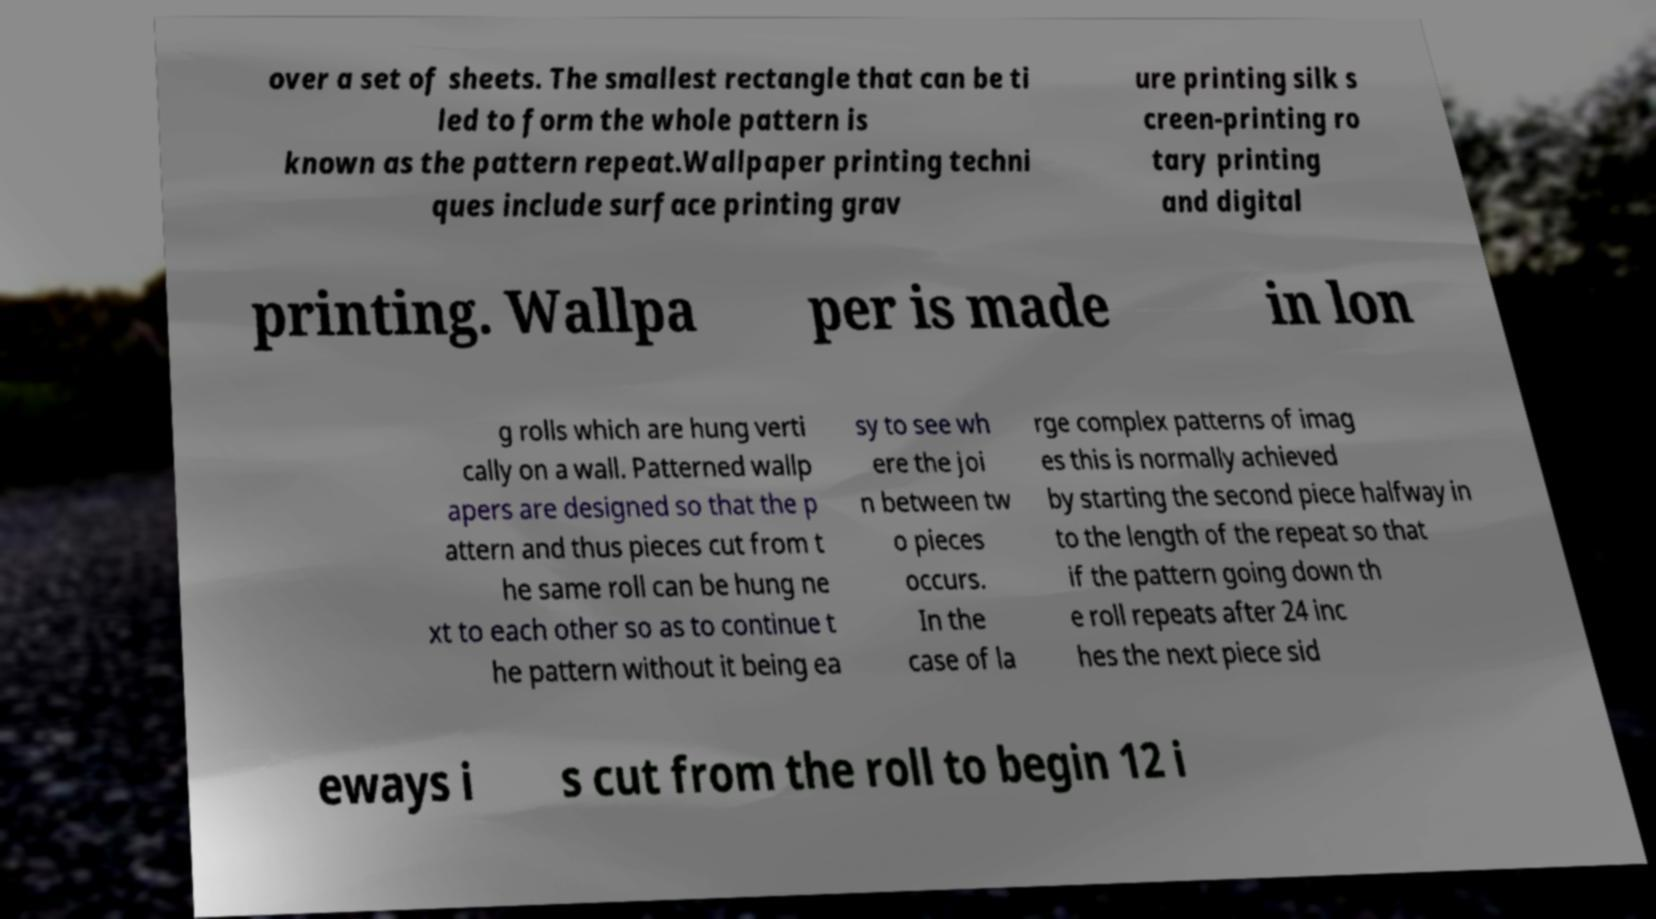Please read and relay the text visible in this image. What does it say? over a set of sheets. The smallest rectangle that can be ti led to form the whole pattern is known as the pattern repeat.Wallpaper printing techni ques include surface printing grav ure printing silk s creen-printing ro tary printing and digital printing. Wallpa per is made in lon g rolls which are hung verti cally on a wall. Patterned wallp apers are designed so that the p attern and thus pieces cut from t he same roll can be hung ne xt to each other so as to continue t he pattern without it being ea sy to see wh ere the joi n between tw o pieces occurs. In the case of la rge complex patterns of imag es this is normally achieved by starting the second piece halfway in to the length of the repeat so that if the pattern going down th e roll repeats after 24 inc hes the next piece sid eways i s cut from the roll to begin 12 i 